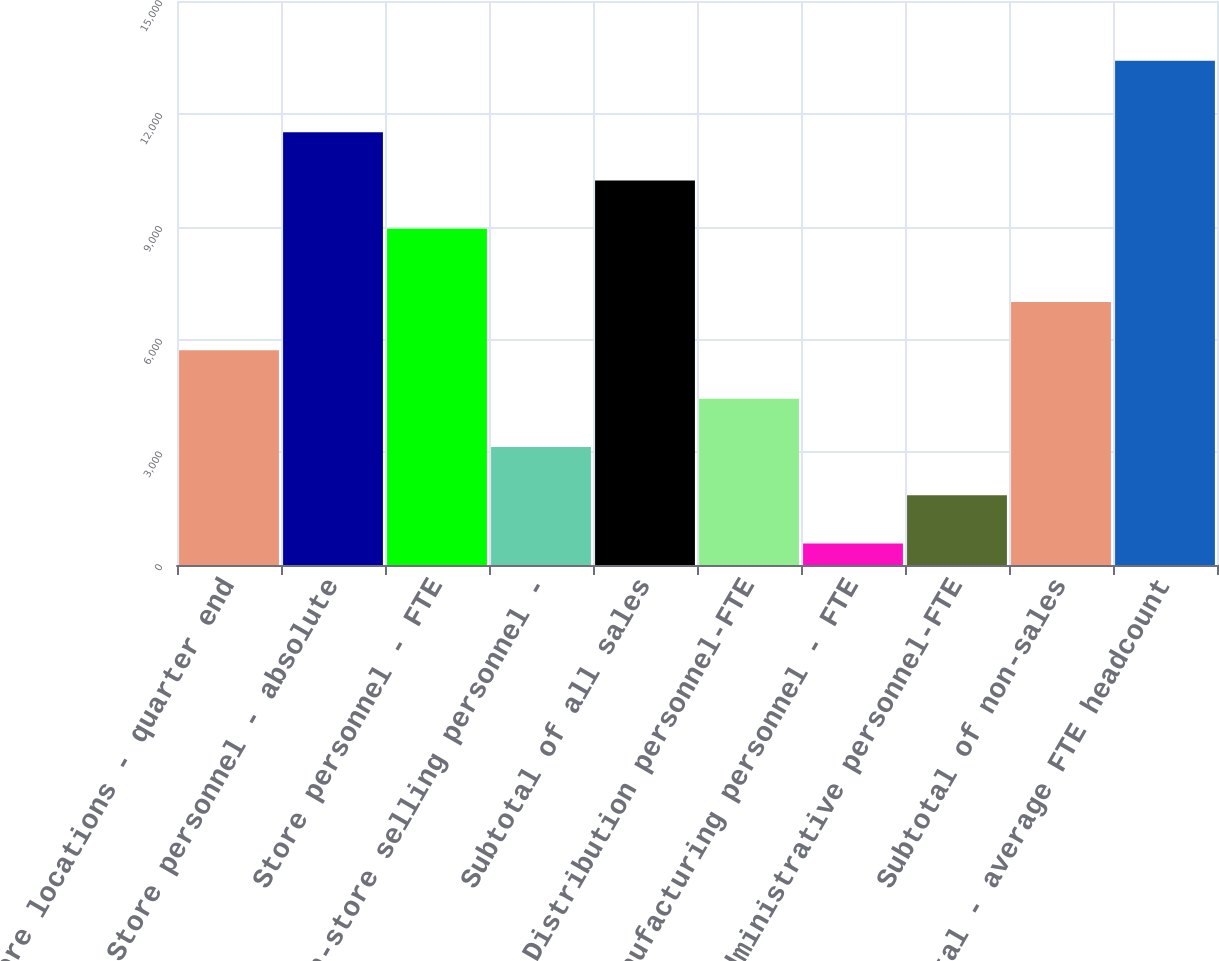Convert chart to OTSL. <chart><loc_0><loc_0><loc_500><loc_500><bar_chart><fcel>Store locations - quarter end<fcel>Store personnel - absolute<fcel>Store personnel - FTE<fcel>Non-store selling personnel -<fcel>Subtotal of all sales<fcel>Distribution personnel-FTE<fcel>Manufacturing personnel - FTE<fcel>Administrative personnel-FTE<fcel>Subtotal of non-sales<fcel>Total - average FTE headcount<nl><fcel>5708.4<fcel>11511.2<fcel>8943<fcel>3140.2<fcel>10227.1<fcel>4424.3<fcel>572<fcel>1856.1<fcel>6992.5<fcel>13413<nl></chart> 